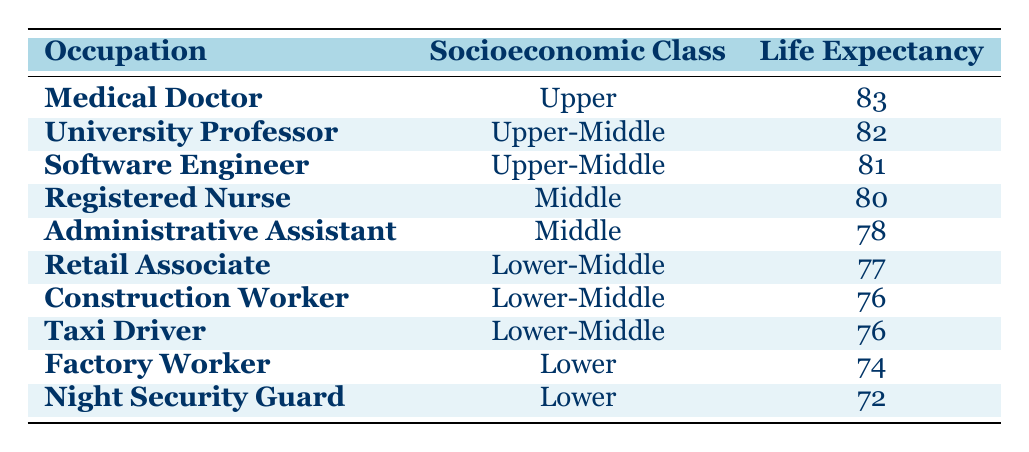What is the life expectancy of a Medical Doctor? The life expectancy of a Medical Doctor is specifically listed in the table. It states that the life expectancy is 83.
Answer: 83 Which occupation has the lowest life expectancy? The table shows the life expectancy for all occupations. The Night Security Guard has the lowest value listed, which is 72.
Answer: 72 What is the average life expectancy for occupations in the Lower-Middle socioeconomic class? The listed occupations in the Lower-Middle class are Retail Associate, Construction Worker, and Taxi Driver. Their life expectancies are 77, 76, and 76 respectively. To find the average: (77 + 76 + 76) / 3 = 229 / 3 = 76.33, which rounds to 76.
Answer: 76.33 Is it true that University Professors have a higher life expectancy than Registered Nurses? The life expectancy for University Professors is 82, while for Registered Nurses it is 80. Since 82 is greater than 80, the statement is true.
Answer: Yes How many years of life expectancy do Factory Workers have compared to Software Engineers? Factory Workers have a life expectancy of 74, and Software Engineers have a life expectancy of 81. The difference is calculated by subtracting 74 from 81, which gives 81 - 74 = 7 years.
Answer: 7 What is the life expectancy difference between the Upper and Lower socioeconomic classes? The life expectancy for the Upper class (Doctors) is 83 and for the Lower class (Night Security Guards) is 72. The difference can be calculated as 83 - 72 = 11 years.
Answer: 11 Do Administrative Assistants have a longer life expectancy than Construction Workers? Administrative Assistants have a life expectancy of 78, while Construction Workers have a life expectancy of 76. Therefore, Administrative Assistants have a longer life expectancy.
Answer: Yes What is the median life expectancy among the provided occupations? To find the median, first list the life expectancies: 72, 74, 76, 76, 77, 78, 80, 81, 82, 83. There are 10 values, so the median is the average of the 5th and 6th values: (77 + 78) / 2 = 77.5.
Answer: 77.5 